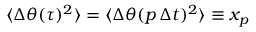<formula> <loc_0><loc_0><loc_500><loc_500>\langle \Delta \theta ( \tau ) ^ { 2 } \rangle = \langle \Delta \theta ( p \, \Delta t ) ^ { 2 } \rangle \equiv x _ { p }</formula> 